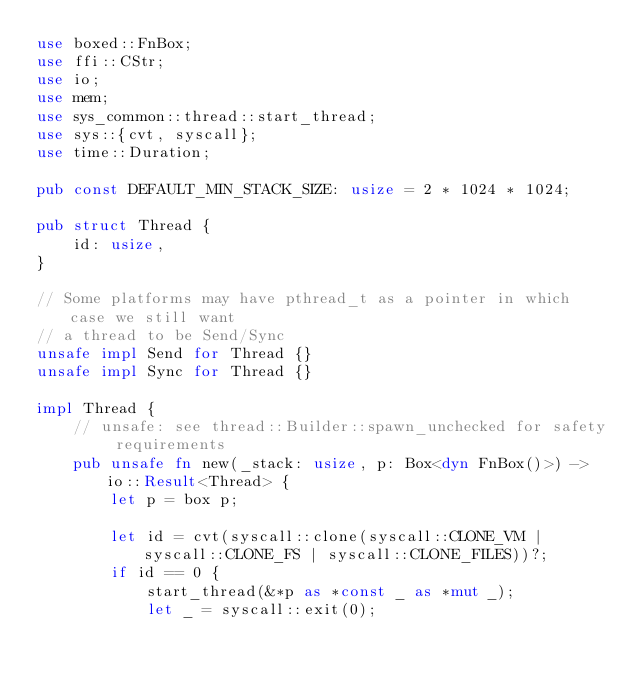Convert code to text. <code><loc_0><loc_0><loc_500><loc_500><_Rust_>use boxed::FnBox;
use ffi::CStr;
use io;
use mem;
use sys_common::thread::start_thread;
use sys::{cvt, syscall};
use time::Duration;

pub const DEFAULT_MIN_STACK_SIZE: usize = 2 * 1024 * 1024;

pub struct Thread {
    id: usize,
}

// Some platforms may have pthread_t as a pointer in which case we still want
// a thread to be Send/Sync
unsafe impl Send for Thread {}
unsafe impl Sync for Thread {}

impl Thread {
    // unsafe: see thread::Builder::spawn_unchecked for safety requirements
    pub unsafe fn new(_stack: usize, p: Box<dyn FnBox()>) -> io::Result<Thread> {
        let p = box p;

        let id = cvt(syscall::clone(syscall::CLONE_VM | syscall::CLONE_FS | syscall::CLONE_FILES))?;
        if id == 0 {
            start_thread(&*p as *const _ as *mut _);
            let _ = syscall::exit(0);</code> 